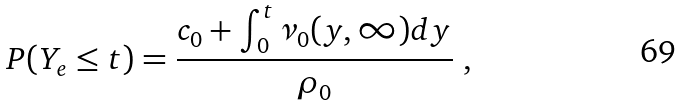Convert formula to latex. <formula><loc_0><loc_0><loc_500><loc_500>P ( Y _ { e } \leq t ) = \frac { c _ { 0 } + \int _ { 0 } ^ { t } \nu _ { 0 } ( y , \infty ) d y } { \rho _ { 0 } } \ ,</formula> 